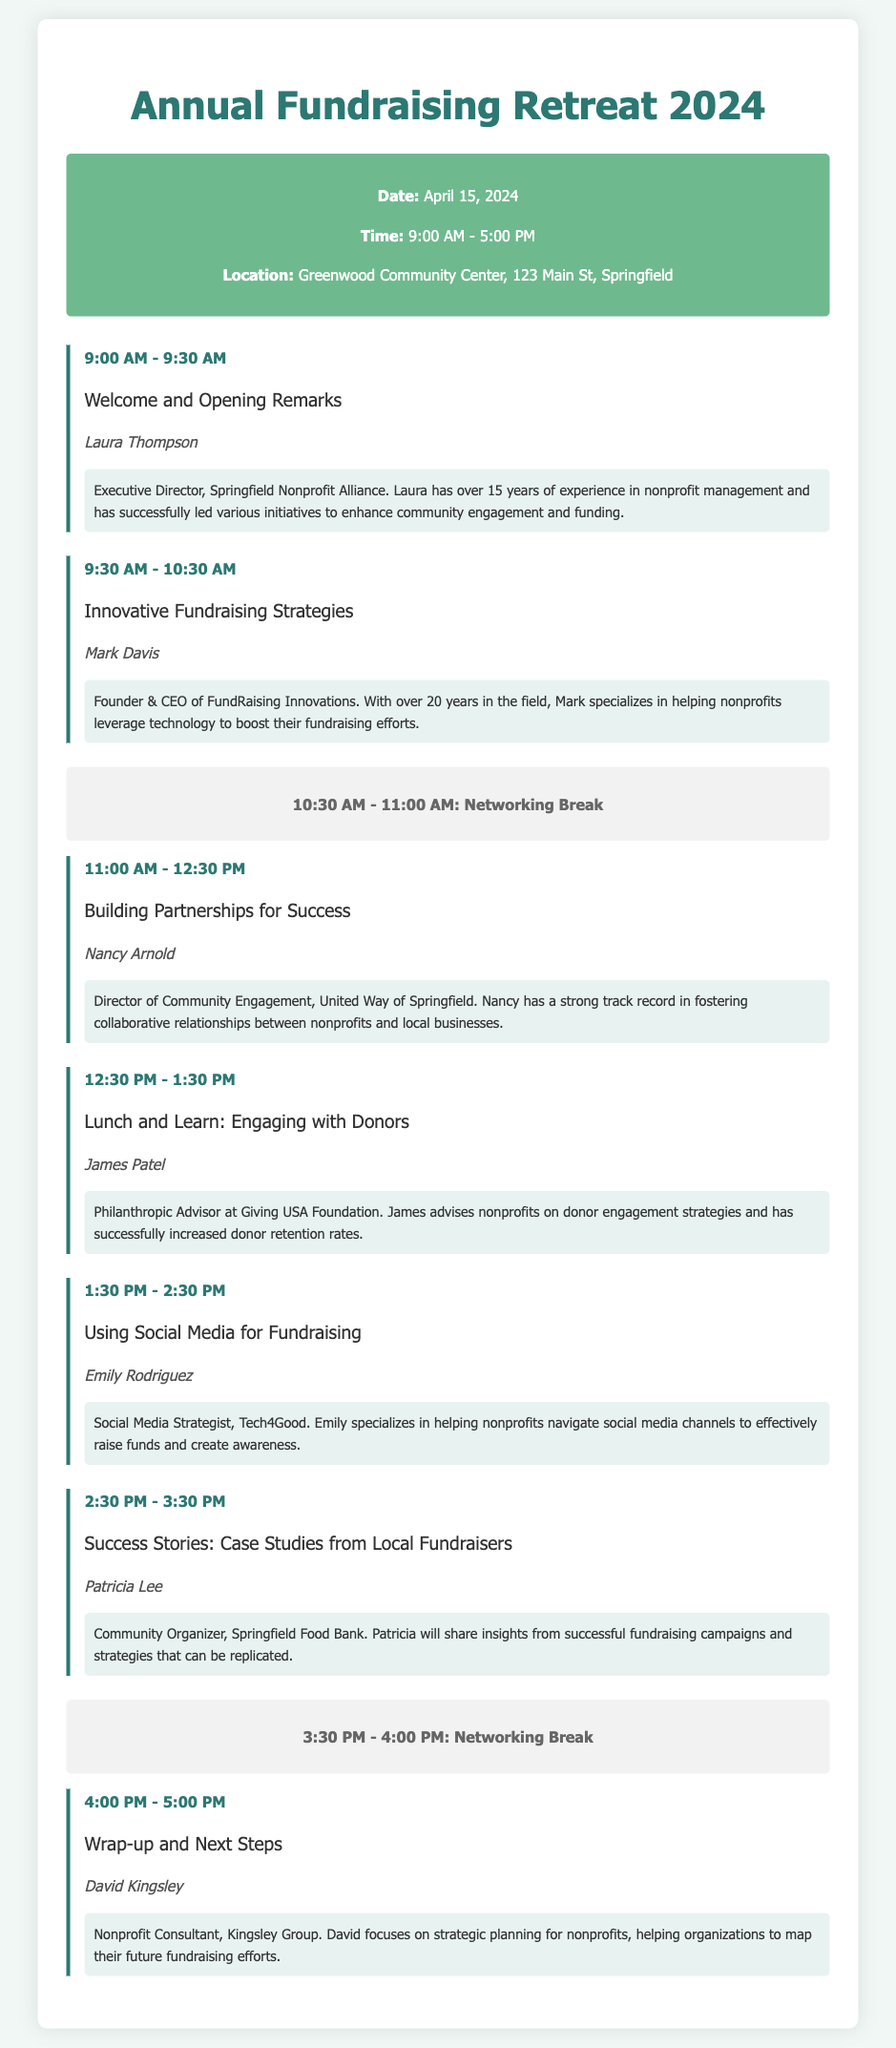What is the date of the retreat? The date is explicitly mentioned in the document as April 15, 2024.
Answer: April 15, 2024 Who is the speaker for the session “Innovative Fundraising Strategies”? The document specifies that Mark Davis is the speaker for this session.
Answer: Mark Davis What time does the session “Lunch and Learn: Engaging with Donors” start? The start time for this session is provided as 12:30 PM.
Answer: 12:30 PM How long is the networking break in the morning? The document states that the networking break lasts from 10:30 AM to 11:00 AM, which is 30 minutes.
Answer: 30 minutes What organization is Laura Thompson affiliated with? The document indicates that Laura is affiliated with the Springfield Nonprofit Alliance.
Answer: Springfield Nonprofit Alliance Who will be speaking on social media fundraising? Emily Rodriguez is listed as the speaker for this session.
Answer: Emily Rodriguez What is the main focus of David Kingsley’s session? The session's main focus is on strategic planning for nonprofits.
Answer: Strategic planning for nonprofits Which session discusses case studies from local fundraisers? The session titled “Success Stories: Case Studies from Local Fundraisers” covers this topic.
Answer: Success Stories: Case Studies from Local Fundraisers 